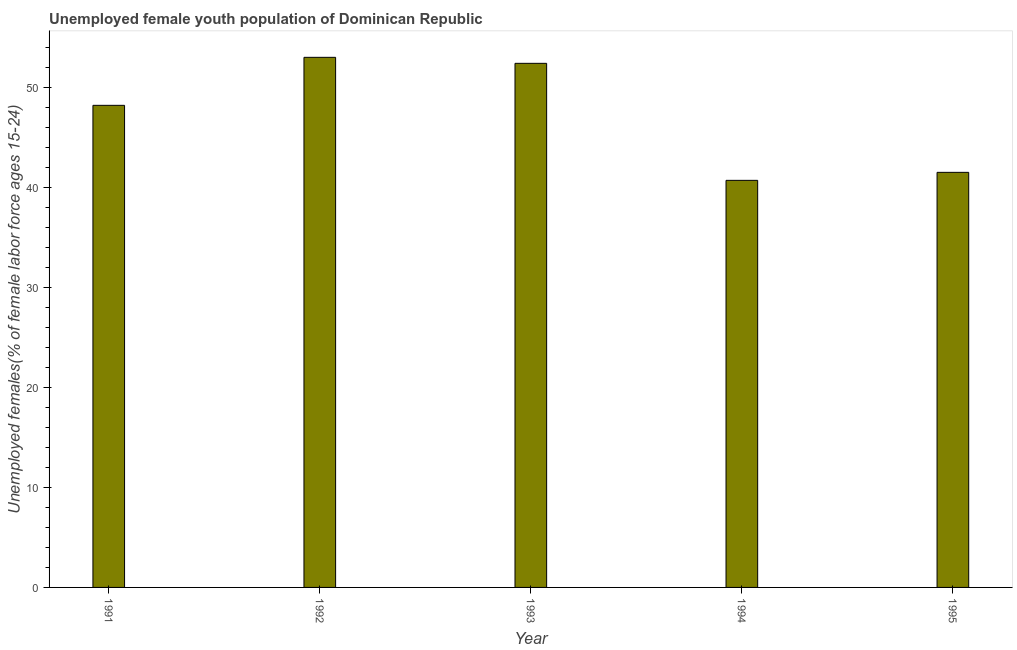Does the graph contain any zero values?
Make the answer very short. No. What is the title of the graph?
Ensure brevity in your answer.  Unemployed female youth population of Dominican Republic. What is the label or title of the X-axis?
Offer a very short reply. Year. What is the label or title of the Y-axis?
Provide a short and direct response. Unemployed females(% of female labor force ages 15-24). What is the unemployed female youth in 1993?
Your response must be concise. 52.4. Across all years, what is the minimum unemployed female youth?
Make the answer very short. 40.7. In which year was the unemployed female youth maximum?
Make the answer very short. 1992. What is the sum of the unemployed female youth?
Your answer should be compact. 235.8. What is the average unemployed female youth per year?
Provide a succinct answer. 47.16. What is the median unemployed female youth?
Make the answer very short. 48.2. Do a majority of the years between 1991 and 1995 (inclusive) have unemployed female youth greater than 52 %?
Provide a succinct answer. No. What is the ratio of the unemployed female youth in 1993 to that in 1995?
Your answer should be very brief. 1.26. Is the unemployed female youth in 1991 less than that in 1994?
Provide a succinct answer. No. What is the difference between the highest and the second highest unemployed female youth?
Make the answer very short. 0.6. How many bars are there?
Keep it short and to the point. 5. How many years are there in the graph?
Your answer should be very brief. 5. What is the difference between two consecutive major ticks on the Y-axis?
Your response must be concise. 10. What is the Unemployed females(% of female labor force ages 15-24) in 1991?
Your response must be concise. 48.2. What is the Unemployed females(% of female labor force ages 15-24) in 1993?
Your answer should be very brief. 52.4. What is the Unemployed females(% of female labor force ages 15-24) of 1994?
Provide a succinct answer. 40.7. What is the Unemployed females(% of female labor force ages 15-24) in 1995?
Keep it short and to the point. 41.5. What is the difference between the Unemployed females(% of female labor force ages 15-24) in 1991 and 1992?
Ensure brevity in your answer.  -4.8. What is the difference between the Unemployed females(% of female labor force ages 15-24) in 1991 and 1993?
Offer a very short reply. -4.2. What is the difference between the Unemployed females(% of female labor force ages 15-24) in 1991 and 1994?
Your response must be concise. 7.5. What is the difference between the Unemployed females(% of female labor force ages 15-24) in 1992 and 1994?
Your answer should be compact. 12.3. What is the ratio of the Unemployed females(% of female labor force ages 15-24) in 1991 to that in 1992?
Provide a short and direct response. 0.91. What is the ratio of the Unemployed females(% of female labor force ages 15-24) in 1991 to that in 1993?
Ensure brevity in your answer.  0.92. What is the ratio of the Unemployed females(% of female labor force ages 15-24) in 1991 to that in 1994?
Your answer should be very brief. 1.18. What is the ratio of the Unemployed females(% of female labor force ages 15-24) in 1991 to that in 1995?
Offer a terse response. 1.16. What is the ratio of the Unemployed females(% of female labor force ages 15-24) in 1992 to that in 1994?
Your answer should be compact. 1.3. What is the ratio of the Unemployed females(% of female labor force ages 15-24) in 1992 to that in 1995?
Make the answer very short. 1.28. What is the ratio of the Unemployed females(% of female labor force ages 15-24) in 1993 to that in 1994?
Keep it short and to the point. 1.29. What is the ratio of the Unemployed females(% of female labor force ages 15-24) in 1993 to that in 1995?
Your answer should be very brief. 1.26. What is the ratio of the Unemployed females(% of female labor force ages 15-24) in 1994 to that in 1995?
Your response must be concise. 0.98. 